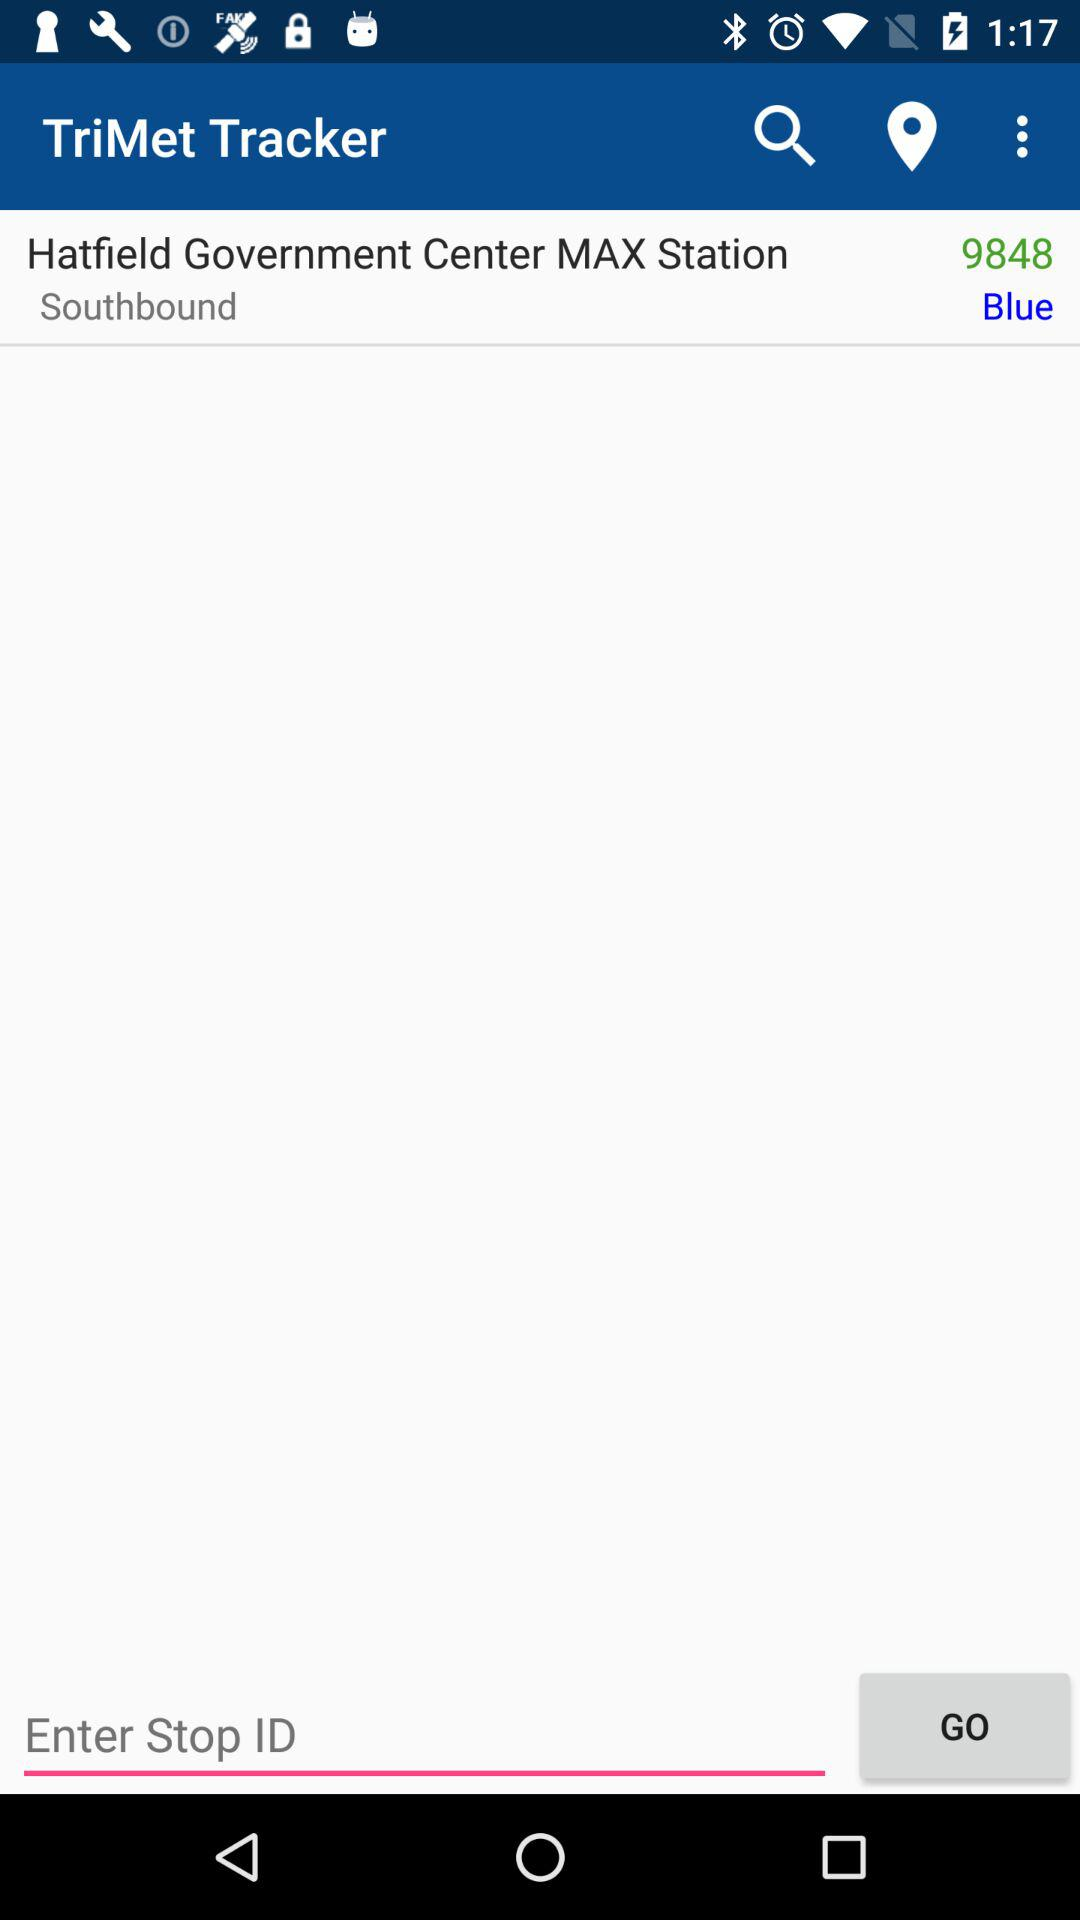What is the location? The location is "Hatfield Government Center MAX Station". 